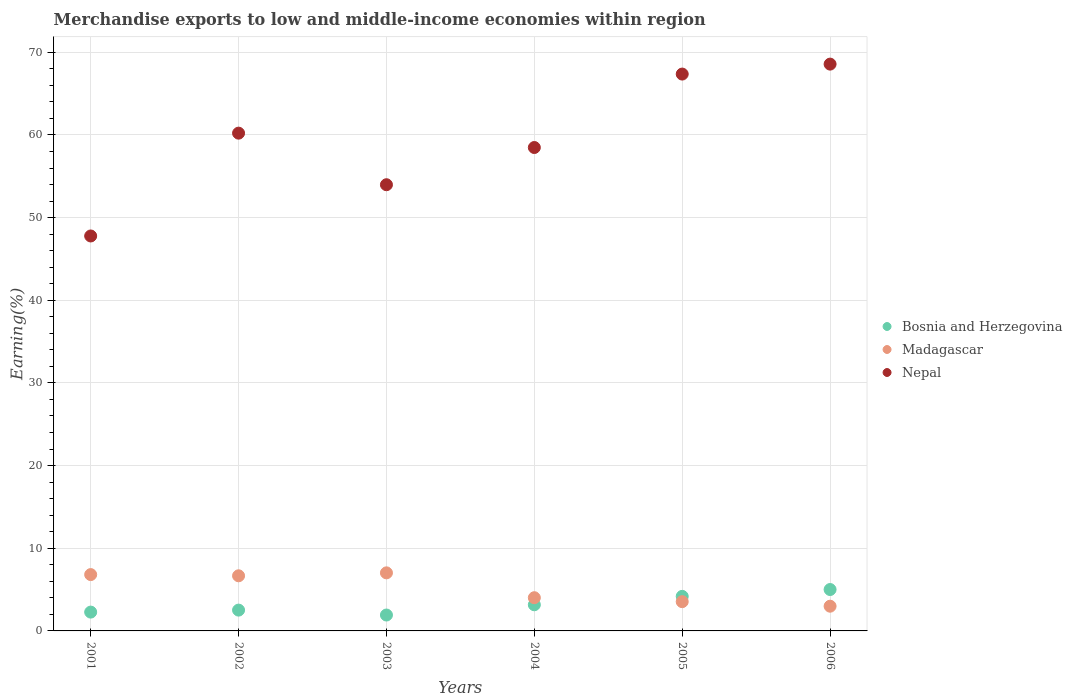Is the number of dotlines equal to the number of legend labels?
Keep it short and to the point. Yes. What is the percentage of amount earned from merchandise exports in Nepal in 2002?
Your answer should be compact. 60.22. Across all years, what is the maximum percentage of amount earned from merchandise exports in Bosnia and Herzegovina?
Offer a terse response. 5.01. Across all years, what is the minimum percentage of amount earned from merchandise exports in Bosnia and Herzegovina?
Your response must be concise. 1.92. In which year was the percentage of amount earned from merchandise exports in Nepal minimum?
Ensure brevity in your answer.  2001. What is the total percentage of amount earned from merchandise exports in Nepal in the graph?
Give a very brief answer. 356.38. What is the difference between the percentage of amount earned from merchandise exports in Nepal in 2002 and that in 2004?
Your answer should be very brief. 1.74. What is the difference between the percentage of amount earned from merchandise exports in Bosnia and Herzegovina in 2005 and the percentage of amount earned from merchandise exports in Madagascar in 2001?
Offer a terse response. -2.63. What is the average percentage of amount earned from merchandise exports in Nepal per year?
Offer a terse response. 59.4. In the year 2004, what is the difference between the percentage of amount earned from merchandise exports in Nepal and percentage of amount earned from merchandise exports in Bosnia and Herzegovina?
Make the answer very short. 55.32. What is the ratio of the percentage of amount earned from merchandise exports in Madagascar in 2001 to that in 2003?
Offer a very short reply. 0.97. Is the percentage of amount earned from merchandise exports in Nepal in 2003 less than that in 2005?
Your answer should be compact. Yes. What is the difference between the highest and the second highest percentage of amount earned from merchandise exports in Nepal?
Keep it short and to the point. 1.2. What is the difference between the highest and the lowest percentage of amount earned from merchandise exports in Nepal?
Ensure brevity in your answer.  20.79. In how many years, is the percentage of amount earned from merchandise exports in Bosnia and Herzegovina greater than the average percentage of amount earned from merchandise exports in Bosnia and Herzegovina taken over all years?
Make the answer very short. 2. Is the percentage of amount earned from merchandise exports in Nepal strictly greater than the percentage of amount earned from merchandise exports in Bosnia and Herzegovina over the years?
Make the answer very short. Yes. How many years are there in the graph?
Your answer should be very brief. 6. Does the graph contain grids?
Ensure brevity in your answer.  Yes. Where does the legend appear in the graph?
Offer a terse response. Center right. What is the title of the graph?
Offer a very short reply. Merchandise exports to low and middle-income economies within region. What is the label or title of the X-axis?
Offer a terse response. Years. What is the label or title of the Y-axis?
Keep it short and to the point. Earning(%). What is the Earning(%) of Bosnia and Herzegovina in 2001?
Your answer should be very brief. 2.28. What is the Earning(%) in Madagascar in 2001?
Keep it short and to the point. 6.81. What is the Earning(%) in Nepal in 2001?
Offer a terse response. 47.78. What is the Earning(%) in Bosnia and Herzegovina in 2002?
Keep it short and to the point. 2.52. What is the Earning(%) of Madagascar in 2002?
Offer a very short reply. 6.67. What is the Earning(%) in Nepal in 2002?
Provide a short and direct response. 60.22. What is the Earning(%) of Bosnia and Herzegovina in 2003?
Your answer should be compact. 1.92. What is the Earning(%) in Madagascar in 2003?
Provide a succinct answer. 7.02. What is the Earning(%) of Nepal in 2003?
Give a very brief answer. 53.98. What is the Earning(%) in Bosnia and Herzegovina in 2004?
Make the answer very short. 3.16. What is the Earning(%) in Madagascar in 2004?
Keep it short and to the point. 4.02. What is the Earning(%) of Nepal in 2004?
Keep it short and to the point. 58.48. What is the Earning(%) in Bosnia and Herzegovina in 2005?
Provide a succinct answer. 4.18. What is the Earning(%) of Madagascar in 2005?
Keep it short and to the point. 3.54. What is the Earning(%) of Nepal in 2005?
Give a very brief answer. 67.36. What is the Earning(%) in Bosnia and Herzegovina in 2006?
Offer a terse response. 5.01. What is the Earning(%) of Madagascar in 2006?
Offer a terse response. 2.99. What is the Earning(%) in Nepal in 2006?
Give a very brief answer. 68.57. Across all years, what is the maximum Earning(%) of Bosnia and Herzegovina?
Keep it short and to the point. 5.01. Across all years, what is the maximum Earning(%) in Madagascar?
Your answer should be compact. 7.02. Across all years, what is the maximum Earning(%) of Nepal?
Your response must be concise. 68.57. Across all years, what is the minimum Earning(%) in Bosnia and Herzegovina?
Give a very brief answer. 1.92. Across all years, what is the minimum Earning(%) in Madagascar?
Provide a succinct answer. 2.99. Across all years, what is the minimum Earning(%) of Nepal?
Make the answer very short. 47.78. What is the total Earning(%) in Bosnia and Herzegovina in the graph?
Provide a short and direct response. 19.07. What is the total Earning(%) in Madagascar in the graph?
Your answer should be very brief. 31.06. What is the total Earning(%) of Nepal in the graph?
Provide a succinct answer. 356.38. What is the difference between the Earning(%) of Bosnia and Herzegovina in 2001 and that in 2002?
Ensure brevity in your answer.  -0.24. What is the difference between the Earning(%) in Madagascar in 2001 and that in 2002?
Offer a terse response. 0.15. What is the difference between the Earning(%) of Nepal in 2001 and that in 2002?
Offer a very short reply. -12.44. What is the difference between the Earning(%) in Bosnia and Herzegovina in 2001 and that in 2003?
Make the answer very short. 0.35. What is the difference between the Earning(%) in Madagascar in 2001 and that in 2003?
Your answer should be very brief. -0.21. What is the difference between the Earning(%) in Nepal in 2001 and that in 2003?
Make the answer very short. -6.2. What is the difference between the Earning(%) in Bosnia and Herzegovina in 2001 and that in 2004?
Offer a very short reply. -0.89. What is the difference between the Earning(%) of Madagascar in 2001 and that in 2004?
Give a very brief answer. 2.8. What is the difference between the Earning(%) of Nepal in 2001 and that in 2004?
Give a very brief answer. -10.7. What is the difference between the Earning(%) in Bosnia and Herzegovina in 2001 and that in 2005?
Provide a short and direct response. -1.9. What is the difference between the Earning(%) of Madagascar in 2001 and that in 2005?
Your answer should be compact. 3.27. What is the difference between the Earning(%) of Nepal in 2001 and that in 2005?
Make the answer very short. -19.59. What is the difference between the Earning(%) in Bosnia and Herzegovina in 2001 and that in 2006?
Make the answer very short. -2.73. What is the difference between the Earning(%) of Madagascar in 2001 and that in 2006?
Your answer should be compact. 3.82. What is the difference between the Earning(%) of Nepal in 2001 and that in 2006?
Provide a short and direct response. -20.79. What is the difference between the Earning(%) of Bosnia and Herzegovina in 2002 and that in 2003?
Your response must be concise. 0.59. What is the difference between the Earning(%) in Madagascar in 2002 and that in 2003?
Offer a very short reply. -0.36. What is the difference between the Earning(%) in Nepal in 2002 and that in 2003?
Give a very brief answer. 6.24. What is the difference between the Earning(%) in Bosnia and Herzegovina in 2002 and that in 2004?
Make the answer very short. -0.64. What is the difference between the Earning(%) of Madagascar in 2002 and that in 2004?
Offer a very short reply. 2.65. What is the difference between the Earning(%) in Nepal in 2002 and that in 2004?
Provide a short and direct response. 1.74. What is the difference between the Earning(%) of Bosnia and Herzegovina in 2002 and that in 2005?
Offer a very short reply. -1.66. What is the difference between the Earning(%) of Madagascar in 2002 and that in 2005?
Offer a very short reply. 3.13. What is the difference between the Earning(%) of Nepal in 2002 and that in 2005?
Offer a very short reply. -7.15. What is the difference between the Earning(%) of Bosnia and Herzegovina in 2002 and that in 2006?
Ensure brevity in your answer.  -2.49. What is the difference between the Earning(%) in Madagascar in 2002 and that in 2006?
Provide a short and direct response. 3.68. What is the difference between the Earning(%) in Nepal in 2002 and that in 2006?
Offer a very short reply. -8.35. What is the difference between the Earning(%) in Bosnia and Herzegovina in 2003 and that in 2004?
Ensure brevity in your answer.  -1.24. What is the difference between the Earning(%) in Madagascar in 2003 and that in 2004?
Provide a short and direct response. 3.01. What is the difference between the Earning(%) of Nepal in 2003 and that in 2004?
Keep it short and to the point. -4.5. What is the difference between the Earning(%) in Bosnia and Herzegovina in 2003 and that in 2005?
Provide a succinct answer. -2.26. What is the difference between the Earning(%) in Madagascar in 2003 and that in 2005?
Give a very brief answer. 3.48. What is the difference between the Earning(%) of Nepal in 2003 and that in 2005?
Provide a succinct answer. -13.39. What is the difference between the Earning(%) of Bosnia and Herzegovina in 2003 and that in 2006?
Give a very brief answer. -3.08. What is the difference between the Earning(%) of Madagascar in 2003 and that in 2006?
Offer a very short reply. 4.03. What is the difference between the Earning(%) of Nepal in 2003 and that in 2006?
Your response must be concise. -14.59. What is the difference between the Earning(%) in Bosnia and Herzegovina in 2004 and that in 2005?
Ensure brevity in your answer.  -1.02. What is the difference between the Earning(%) in Madagascar in 2004 and that in 2005?
Give a very brief answer. 0.48. What is the difference between the Earning(%) of Nepal in 2004 and that in 2005?
Keep it short and to the point. -8.89. What is the difference between the Earning(%) in Bosnia and Herzegovina in 2004 and that in 2006?
Ensure brevity in your answer.  -1.85. What is the difference between the Earning(%) of Madagascar in 2004 and that in 2006?
Offer a very short reply. 1.03. What is the difference between the Earning(%) in Nepal in 2004 and that in 2006?
Provide a succinct answer. -10.09. What is the difference between the Earning(%) in Bosnia and Herzegovina in 2005 and that in 2006?
Offer a very short reply. -0.83. What is the difference between the Earning(%) in Madagascar in 2005 and that in 2006?
Provide a succinct answer. 0.55. What is the difference between the Earning(%) of Nepal in 2005 and that in 2006?
Your response must be concise. -1.2. What is the difference between the Earning(%) of Bosnia and Herzegovina in 2001 and the Earning(%) of Madagascar in 2002?
Make the answer very short. -4.39. What is the difference between the Earning(%) of Bosnia and Herzegovina in 2001 and the Earning(%) of Nepal in 2002?
Offer a terse response. -57.94. What is the difference between the Earning(%) in Madagascar in 2001 and the Earning(%) in Nepal in 2002?
Provide a short and direct response. -53.4. What is the difference between the Earning(%) of Bosnia and Herzegovina in 2001 and the Earning(%) of Madagascar in 2003?
Provide a short and direct response. -4.75. What is the difference between the Earning(%) in Bosnia and Herzegovina in 2001 and the Earning(%) in Nepal in 2003?
Your response must be concise. -51.7. What is the difference between the Earning(%) in Madagascar in 2001 and the Earning(%) in Nepal in 2003?
Ensure brevity in your answer.  -47.16. What is the difference between the Earning(%) in Bosnia and Herzegovina in 2001 and the Earning(%) in Madagascar in 2004?
Offer a very short reply. -1.74. What is the difference between the Earning(%) in Bosnia and Herzegovina in 2001 and the Earning(%) in Nepal in 2004?
Provide a succinct answer. -56.2. What is the difference between the Earning(%) in Madagascar in 2001 and the Earning(%) in Nepal in 2004?
Provide a short and direct response. -51.66. What is the difference between the Earning(%) of Bosnia and Herzegovina in 2001 and the Earning(%) of Madagascar in 2005?
Offer a very short reply. -1.26. What is the difference between the Earning(%) of Bosnia and Herzegovina in 2001 and the Earning(%) of Nepal in 2005?
Make the answer very short. -65.09. What is the difference between the Earning(%) of Madagascar in 2001 and the Earning(%) of Nepal in 2005?
Your answer should be very brief. -60.55. What is the difference between the Earning(%) of Bosnia and Herzegovina in 2001 and the Earning(%) of Madagascar in 2006?
Offer a terse response. -0.71. What is the difference between the Earning(%) of Bosnia and Herzegovina in 2001 and the Earning(%) of Nepal in 2006?
Make the answer very short. -66.29. What is the difference between the Earning(%) in Madagascar in 2001 and the Earning(%) in Nepal in 2006?
Give a very brief answer. -61.75. What is the difference between the Earning(%) of Bosnia and Herzegovina in 2002 and the Earning(%) of Madagascar in 2003?
Provide a short and direct response. -4.51. What is the difference between the Earning(%) in Bosnia and Herzegovina in 2002 and the Earning(%) in Nepal in 2003?
Offer a terse response. -51.46. What is the difference between the Earning(%) in Madagascar in 2002 and the Earning(%) in Nepal in 2003?
Ensure brevity in your answer.  -47.31. What is the difference between the Earning(%) of Bosnia and Herzegovina in 2002 and the Earning(%) of Madagascar in 2004?
Make the answer very short. -1.5. What is the difference between the Earning(%) in Bosnia and Herzegovina in 2002 and the Earning(%) in Nepal in 2004?
Make the answer very short. -55.96. What is the difference between the Earning(%) of Madagascar in 2002 and the Earning(%) of Nepal in 2004?
Offer a terse response. -51.81. What is the difference between the Earning(%) of Bosnia and Herzegovina in 2002 and the Earning(%) of Madagascar in 2005?
Give a very brief answer. -1.02. What is the difference between the Earning(%) in Bosnia and Herzegovina in 2002 and the Earning(%) in Nepal in 2005?
Offer a very short reply. -64.85. What is the difference between the Earning(%) in Madagascar in 2002 and the Earning(%) in Nepal in 2005?
Your response must be concise. -60.7. What is the difference between the Earning(%) of Bosnia and Herzegovina in 2002 and the Earning(%) of Madagascar in 2006?
Provide a succinct answer. -0.47. What is the difference between the Earning(%) in Bosnia and Herzegovina in 2002 and the Earning(%) in Nepal in 2006?
Provide a short and direct response. -66.05. What is the difference between the Earning(%) of Madagascar in 2002 and the Earning(%) of Nepal in 2006?
Make the answer very short. -61.9. What is the difference between the Earning(%) in Bosnia and Herzegovina in 2003 and the Earning(%) in Madagascar in 2004?
Offer a terse response. -2.09. What is the difference between the Earning(%) of Bosnia and Herzegovina in 2003 and the Earning(%) of Nepal in 2004?
Your response must be concise. -56.56. What is the difference between the Earning(%) of Madagascar in 2003 and the Earning(%) of Nepal in 2004?
Offer a very short reply. -51.45. What is the difference between the Earning(%) of Bosnia and Herzegovina in 2003 and the Earning(%) of Madagascar in 2005?
Ensure brevity in your answer.  -1.62. What is the difference between the Earning(%) of Bosnia and Herzegovina in 2003 and the Earning(%) of Nepal in 2005?
Offer a very short reply. -65.44. What is the difference between the Earning(%) of Madagascar in 2003 and the Earning(%) of Nepal in 2005?
Your response must be concise. -60.34. What is the difference between the Earning(%) of Bosnia and Herzegovina in 2003 and the Earning(%) of Madagascar in 2006?
Your response must be concise. -1.07. What is the difference between the Earning(%) in Bosnia and Herzegovina in 2003 and the Earning(%) in Nepal in 2006?
Ensure brevity in your answer.  -66.64. What is the difference between the Earning(%) in Madagascar in 2003 and the Earning(%) in Nepal in 2006?
Keep it short and to the point. -61.54. What is the difference between the Earning(%) of Bosnia and Herzegovina in 2004 and the Earning(%) of Madagascar in 2005?
Ensure brevity in your answer.  -0.38. What is the difference between the Earning(%) of Bosnia and Herzegovina in 2004 and the Earning(%) of Nepal in 2005?
Make the answer very short. -64.2. What is the difference between the Earning(%) in Madagascar in 2004 and the Earning(%) in Nepal in 2005?
Your answer should be compact. -63.35. What is the difference between the Earning(%) of Bosnia and Herzegovina in 2004 and the Earning(%) of Madagascar in 2006?
Your answer should be very brief. 0.17. What is the difference between the Earning(%) in Bosnia and Herzegovina in 2004 and the Earning(%) in Nepal in 2006?
Keep it short and to the point. -65.41. What is the difference between the Earning(%) in Madagascar in 2004 and the Earning(%) in Nepal in 2006?
Your answer should be very brief. -64.55. What is the difference between the Earning(%) of Bosnia and Herzegovina in 2005 and the Earning(%) of Madagascar in 2006?
Offer a very short reply. 1.19. What is the difference between the Earning(%) in Bosnia and Herzegovina in 2005 and the Earning(%) in Nepal in 2006?
Provide a succinct answer. -64.39. What is the difference between the Earning(%) in Madagascar in 2005 and the Earning(%) in Nepal in 2006?
Your answer should be compact. -65.03. What is the average Earning(%) of Bosnia and Herzegovina per year?
Your answer should be compact. 3.18. What is the average Earning(%) of Madagascar per year?
Your answer should be compact. 5.18. What is the average Earning(%) of Nepal per year?
Provide a succinct answer. 59.4. In the year 2001, what is the difference between the Earning(%) of Bosnia and Herzegovina and Earning(%) of Madagascar?
Give a very brief answer. -4.54. In the year 2001, what is the difference between the Earning(%) in Bosnia and Herzegovina and Earning(%) in Nepal?
Make the answer very short. -45.5. In the year 2001, what is the difference between the Earning(%) of Madagascar and Earning(%) of Nepal?
Your response must be concise. -40.96. In the year 2002, what is the difference between the Earning(%) of Bosnia and Herzegovina and Earning(%) of Madagascar?
Provide a short and direct response. -4.15. In the year 2002, what is the difference between the Earning(%) of Bosnia and Herzegovina and Earning(%) of Nepal?
Provide a succinct answer. -57.7. In the year 2002, what is the difference between the Earning(%) of Madagascar and Earning(%) of Nepal?
Make the answer very short. -53.55. In the year 2003, what is the difference between the Earning(%) of Bosnia and Herzegovina and Earning(%) of Madagascar?
Provide a short and direct response. -5.1. In the year 2003, what is the difference between the Earning(%) of Bosnia and Herzegovina and Earning(%) of Nepal?
Give a very brief answer. -52.05. In the year 2003, what is the difference between the Earning(%) of Madagascar and Earning(%) of Nepal?
Your answer should be very brief. -46.95. In the year 2004, what is the difference between the Earning(%) in Bosnia and Herzegovina and Earning(%) in Madagascar?
Keep it short and to the point. -0.85. In the year 2004, what is the difference between the Earning(%) of Bosnia and Herzegovina and Earning(%) of Nepal?
Your response must be concise. -55.32. In the year 2004, what is the difference between the Earning(%) of Madagascar and Earning(%) of Nepal?
Provide a short and direct response. -54.46. In the year 2005, what is the difference between the Earning(%) in Bosnia and Herzegovina and Earning(%) in Madagascar?
Ensure brevity in your answer.  0.64. In the year 2005, what is the difference between the Earning(%) of Bosnia and Herzegovina and Earning(%) of Nepal?
Give a very brief answer. -63.18. In the year 2005, what is the difference between the Earning(%) of Madagascar and Earning(%) of Nepal?
Your response must be concise. -63.82. In the year 2006, what is the difference between the Earning(%) of Bosnia and Herzegovina and Earning(%) of Madagascar?
Keep it short and to the point. 2.02. In the year 2006, what is the difference between the Earning(%) in Bosnia and Herzegovina and Earning(%) in Nepal?
Your answer should be compact. -63.56. In the year 2006, what is the difference between the Earning(%) in Madagascar and Earning(%) in Nepal?
Offer a very short reply. -65.58. What is the ratio of the Earning(%) in Bosnia and Herzegovina in 2001 to that in 2002?
Give a very brief answer. 0.9. What is the ratio of the Earning(%) of Madagascar in 2001 to that in 2002?
Your response must be concise. 1.02. What is the ratio of the Earning(%) in Nepal in 2001 to that in 2002?
Offer a terse response. 0.79. What is the ratio of the Earning(%) in Bosnia and Herzegovina in 2001 to that in 2003?
Your answer should be compact. 1.18. What is the ratio of the Earning(%) of Madagascar in 2001 to that in 2003?
Provide a short and direct response. 0.97. What is the ratio of the Earning(%) in Nepal in 2001 to that in 2003?
Give a very brief answer. 0.89. What is the ratio of the Earning(%) of Bosnia and Herzegovina in 2001 to that in 2004?
Give a very brief answer. 0.72. What is the ratio of the Earning(%) of Madagascar in 2001 to that in 2004?
Your answer should be very brief. 1.7. What is the ratio of the Earning(%) of Nepal in 2001 to that in 2004?
Your answer should be very brief. 0.82. What is the ratio of the Earning(%) in Bosnia and Herzegovina in 2001 to that in 2005?
Offer a terse response. 0.54. What is the ratio of the Earning(%) in Madagascar in 2001 to that in 2005?
Offer a very short reply. 1.92. What is the ratio of the Earning(%) of Nepal in 2001 to that in 2005?
Your answer should be compact. 0.71. What is the ratio of the Earning(%) of Bosnia and Herzegovina in 2001 to that in 2006?
Your answer should be compact. 0.45. What is the ratio of the Earning(%) in Madagascar in 2001 to that in 2006?
Your response must be concise. 2.28. What is the ratio of the Earning(%) in Nepal in 2001 to that in 2006?
Make the answer very short. 0.7. What is the ratio of the Earning(%) in Bosnia and Herzegovina in 2002 to that in 2003?
Your answer should be compact. 1.31. What is the ratio of the Earning(%) of Madagascar in 2002 to that in 2003?
Offer a terse response. 0.95. What is the ratio of the Earning(%) in Nepal in 2002 to that in 2003?
Make the answer very short. 1.12. What is the ratio of the Earning(%) of Bosnia and Herzegovina in 2002 to that in 2004?
Your response must be concise. 0.8. What is the ratio of the Earning(%) of Madagascar in 2002 to that in 2004?
Ensure brevity in your answer.  1.66. What is the ratio of the Earning(%) of Nepal in 2002 to that in 2004?
Provide a succinct answer. 1.03. What is the ratio of the Earning(%) in Bosnia and Herzegovina in 2002 to that in 2005?
Provide a succinct answer. 0.6. What is the ratio of the Earning(%) of Madagascar in 2002 to that in 2005?
Your answer should be very brief. 1.88. What is the ratio of the Earning(%) in Nepal in 2002 to that in 2005?
Provide a short and direct response. 0.89. What is the ratio of the Earning(%) in Bosnia and Herzegovina in 2002 to that in 2006?
Offer a very short reply. 0.5. What is the ratio of the Earning(%) of Madagascar in 2002 to that in 2006?
Give a very brief answer. 2.23. What is the ratio of the Earning(%) in Nepal in 2002 to that in 2006?
Your answer should be compact. 0.88. What is the ratio of the Earning(%) in Bosnia and Herzegovina in 2003 to that in 2004?
Make the answer very short. 0.61. What is the ratio of the Earning(%) in Madagascar in 2003 to that in 2004?
Provide a short and direct response. 1.75. What is the ratio of the Earning(%) in Nepal in 2003 to that in 2004?
Your answer should be very brief. 0.92. What is the ratio of the Earning(%) in Bosnia and Herzegovina in 2003 to that in 2005?
Make the answer very short. 0.46. What is the ratio of the Earning(%) in Madagascar in 2003 to that in 2005?
Give a very brief answer. 1.98. What is the ratio of the Earning(%) in Nepal in 2003 to that in 2005?
Keep it short and to the point. 0.8. What is the ratio of the Earning(%) of Bosnia and Herzegovina in 2003 to that in 2006?
Give a very brief answer. 0.38. What is the ratio of the Earning(%) in Madagascar in 2003 to that in 2006?
Keep it short and to the point. 2.35. What is the ratio of the Earning(%) of Nepal in 2003 to that in 2006?
Keep it short and to the point. 0.79. What is the ratio of the Earning(%) in Bosnia and Herzegovina in 2004 to that in 2005?
Make the answer very short. 0.76. What is the ratio of the Earning(%) of Madagascar in 2004 to that in 2005?
Make the answer very short. 1.13. What is the ratio of the Earning(%) of Nepal in 2004 to that in 2005?
Make the answer very short. 0.87. What is the ratio of the Earning(%) in Bosnia and Herzegovina in 2004 to that in 2006?
Offer a very short reply. 0.63. What is the ratio of the Earning(%) of Madagascar in 2004 to that in 2006?
Keep it short and to the point. 1.34. What is the ratio of the Earning(%) of Nepal in 2004 to that in 2006?
Give a very brief answer. 0.85. What is the ratio of the Earning(%) of Bosnia and Herzegovina in 2005 to that in 2006?
Your answer should be compact. 0.83. What is the ratio of the Earning(%) of Madagascar in 2005 to that in 2006?
Your answer should be very brief. 1.18. What is the ratio of the Earning(%) of Nepal in 2005 to that in 2006?
Offer a very short reply. 0.98. What is the difference between the highest and the second highest Earning(%) of Bosnia and Herzegovina?
Make the answer very short. 0.83. What is the difference between the highest and the second highest Earning(%) of Madagascar?
Provide a short and direct response. 0.21. What is the difference between the highest and the second highest Earning(%) in Nepal?
Your answer should be very brief. 1.2. What is the difference between the highest and the lowest Earning(%) in Bosnia and Herzegovina?
Your response must be concise. 3.08. What is the difference between the highest and the lowest Earning(%) in Madagascar?
Provide a short and direct response. 4.03. What is the difference between the highest and the lowest Earning(%) of Nepal?
Your response must be concise. 20.79. 